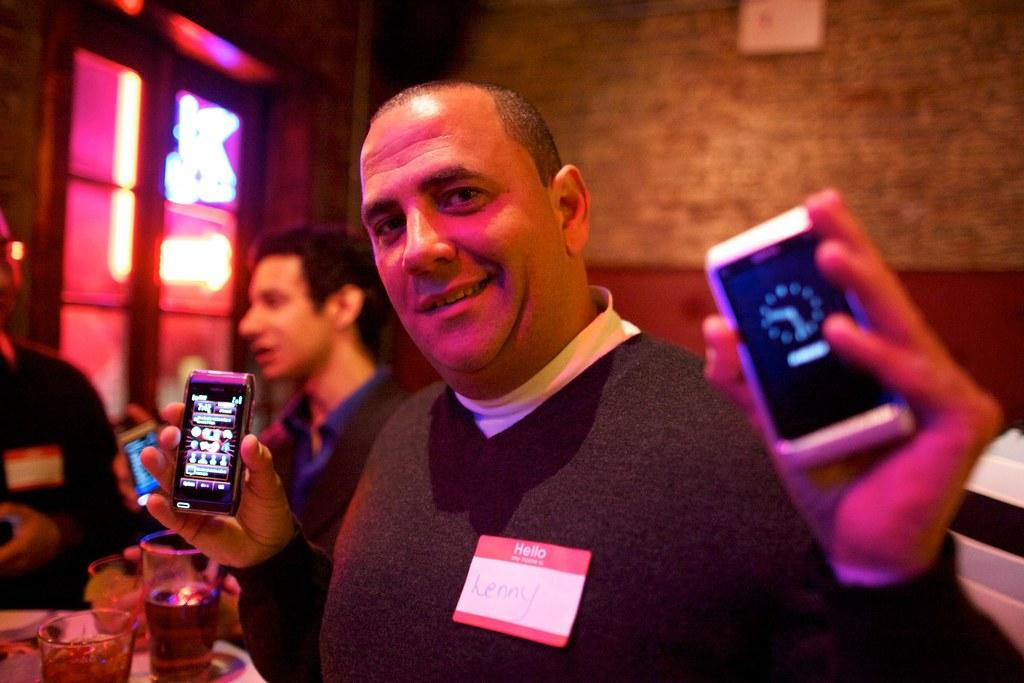<image>
Offer a succinct explanation of the picture presented. a man with a Hello my name is Lenny sticker holds up two phones 